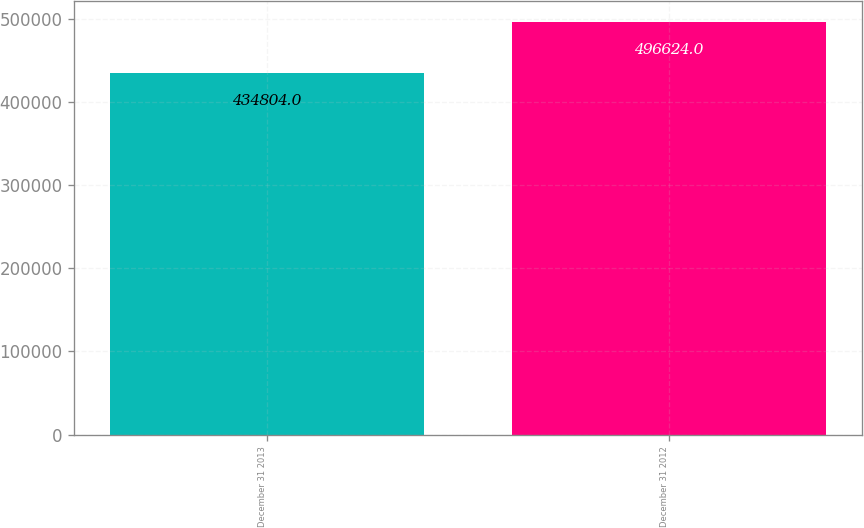Convert chart. <chart><loc_0><loc_0><loc_500><loc_500><bar_chart><fcel>December 31 2013<fcel>December 31 2012<nl><fcel>434804<fcel>496624<nl></chart> 